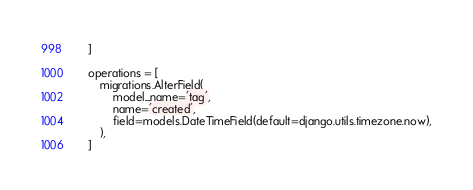<code> <loc_0><loc_0><loc_500><loc_500><_Python_>    ]

    operations = [
        migrations.AlterField(
            model_name='tag',
            name='created',
            field=models.DateTimeField(default=django.utils.timezone.now),
        ),
    ]
</code> 